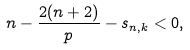Convert formula to latex. <formula><loc_0><loc_0><loc_500><loc_500>n - \frac { 2 ( n + 2 ) } { p } - s _ { n , k } < 0 ,</formula> 